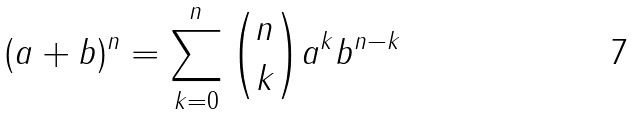Convert formula to latex. <formula><loc_0><loc_0><loc_500><loc_500>( a + b ) ^ { n } = \sum _ { k = 0 } ^ { n } { \binom { n } { k } } a ^ { k } b ^ { n - k }</formula> 